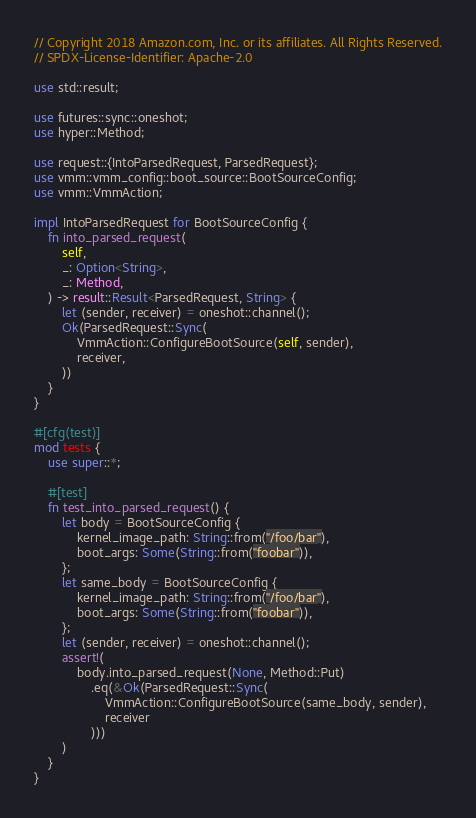Convert code to text. <code><loc_0><loc_0><loc_500><loc_500><_Rust_>// Copyright 2018 Amazon.com, Inc. or its affiliates. All Rights Reserved.
// SPDX-License-Identifier: Apache-2.0

use std::result;

use futures::sync::oneshot;
use hyper::Method;

use request::{IntoParsedRequest, ParsedRequest};
use vmm::vmm_config::boot_source::BootSourceConfig;
use vmm::VmmAction;

impl IntoParsedRequest for BootSourceConfig {
    fn into_parsed_request(
        self,
        _: Option<String>,
        _: Method,
    ) -> result::Result<ParsedRequest, String> {
        let (sender, receiver) = oneshot::channel();
        Ok(ParsedRequest::Sync(
            VmmAction::ConfigureBootSource(self, sender),
            receiver,
        ))
    }
}

#[cfg(test)]
mod tests {
    use super::*;

    #[test]
    fn test_into_parsed_request() {
        let body = BootSourceConfig {
            kernel_image_path: String::from("/foo/bar"),
            boot_args: Some(String::from("foobar")),
        };
        let same_body = BootSourceConfig {
            kernel_image_path: String::from("/foo/bar"),
            boot_args: Some(String::from("foobar")),
        };
        let (sender, receiver) = oneshot::channel();
        assert!(
            body.into_parsed_request(None, Method::Put)
                .eq(&Ok(ParsedRequest::Sync(
                    VmmAction::ConfigureBootSource(same_body, sender),
                    receiver
                )))
        )
    }
}
</code> 